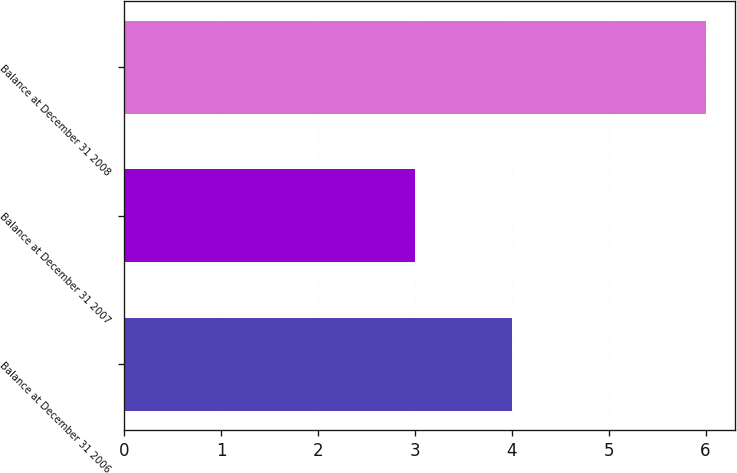Convert chart. <chart><loc_0><loc_0><loc_500><loc_500><bar_chart><fcel>Balance at December 31 2006<fcel>Balance at December 31 2007<fcel>Balance at December 31 2008<nl><fcel>4<fcel>3<fcel>6<nl></chart> 